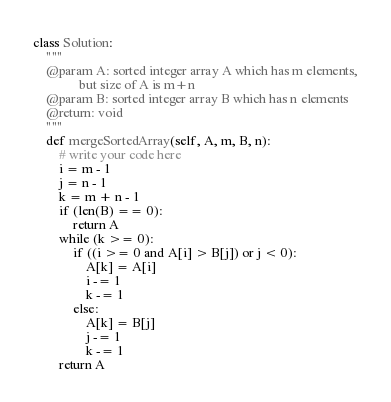<code> <loc_0><loc_0><loc_500><loc_500><_Python_>class Solution:
    """
    @param A: sorted integer array A which has m elements,
              but size of A is m+n
    @param B: sorted integer array B which has n elements
    @return: void
    """
    def mergeSortedArray(self, A, m, B, n):
        # write your code here
        i = m - 1
        j = n - 1
        k = m + n - 1
        if (len(B) == 0):
            return A
        while (k >= 0):
            if ((i >= 0 and A[i] > B[j]) or j < 0):
                A[k] = A[i]
                i -= 1
                k -= 1
            else:
                A[k] = B[j]
                j -= 1
                k -= 1
        return A
</code> 